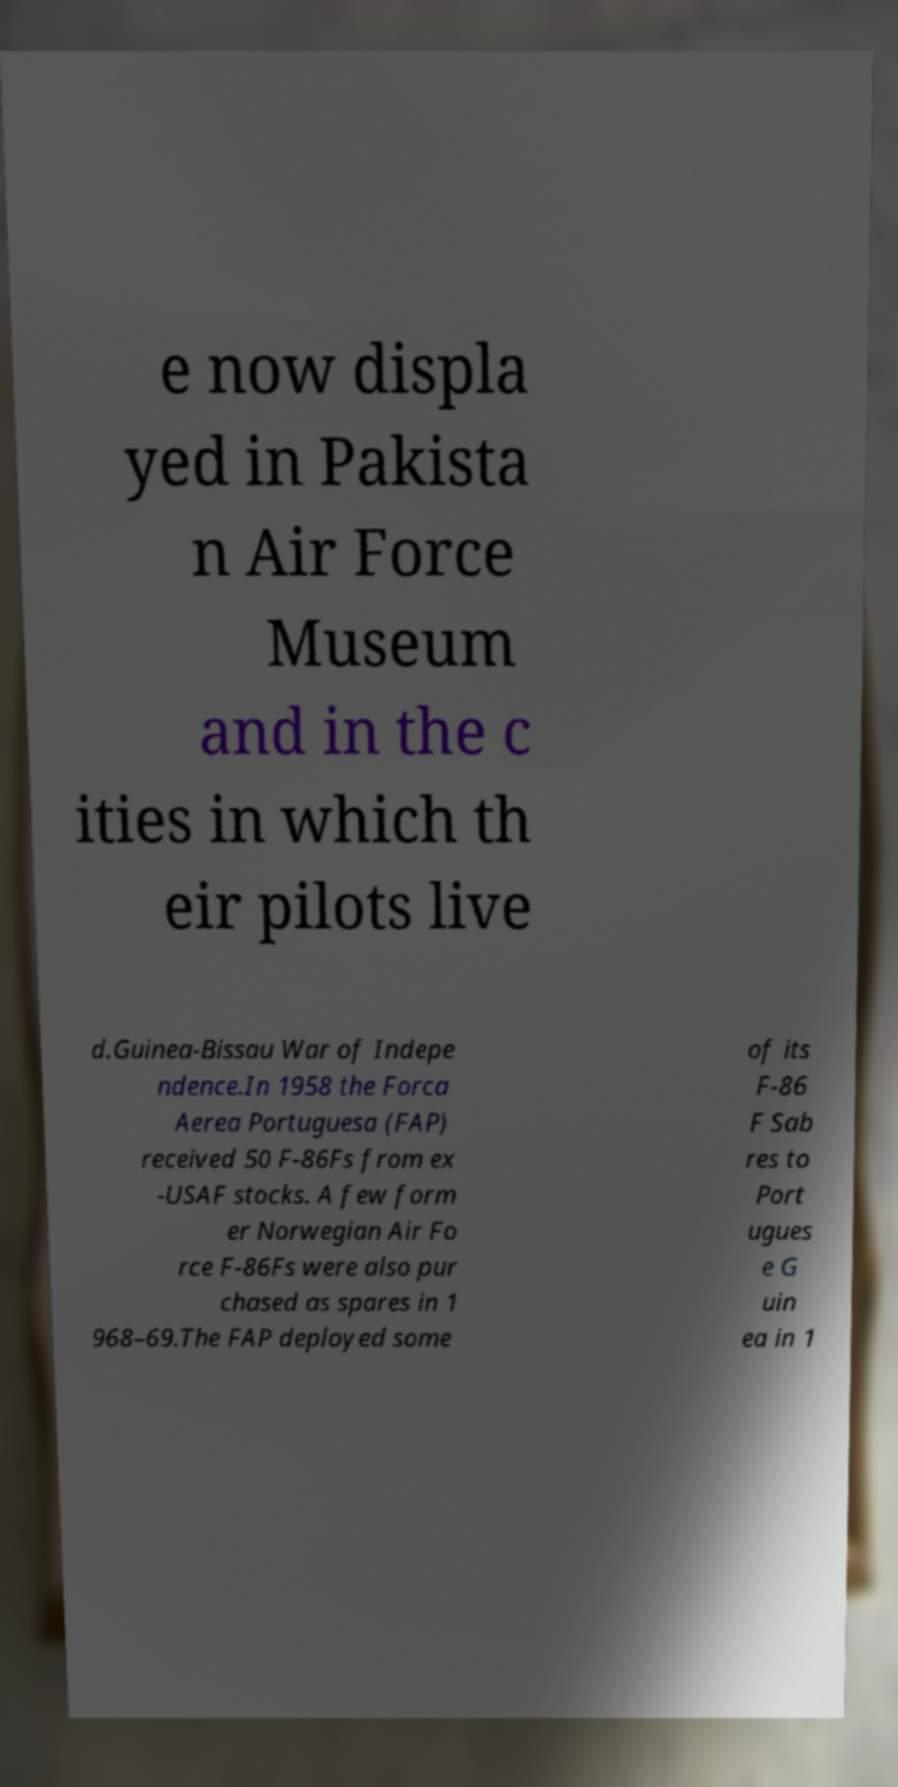Please identify and transcribe the text found in this image. e now displa yed in Pakista n Air Force Museum and in the c ities in which th eir pilots live d.Guinea-Bissau War of Indepe ndence.In 1958 the Forca Aerea Portuguesa (FAP) received 50 F-86Fs from ex -USAF stocks. A few form er Norwegian Air Fo rce F-86Fs were also pur chased as spares in 1 968–69.The FAP deployed some of its F-86 F Sab res to Port ugues e G uin ea in 1 